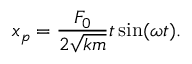Convert formula to latex. <formula><loc_0><loc_0><loc_500><loc_500>x _ { p } = { \frac { F _ { 0 } } { 2 { \sqrt { k m } } } } t \sin ( \omega t ) .</formula> 